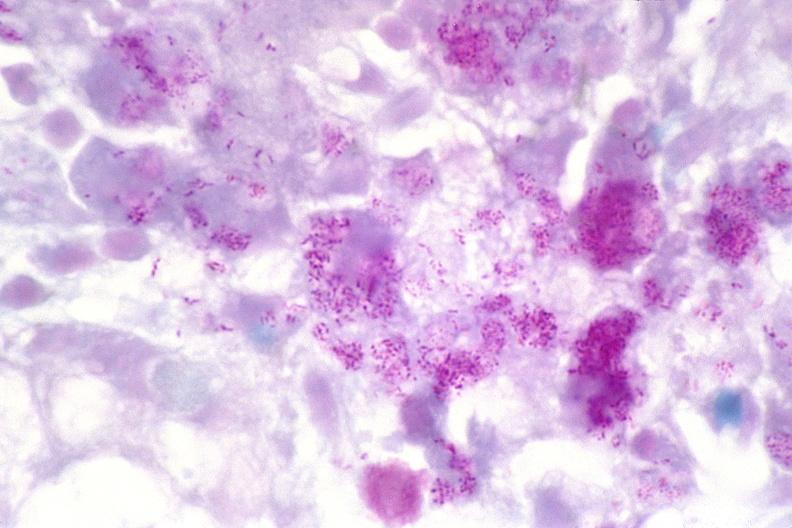does left ventricle hypertrophy show lymph node, mycobacterium avium-intracellularae?
Answer the question using a single word or phrase. No 